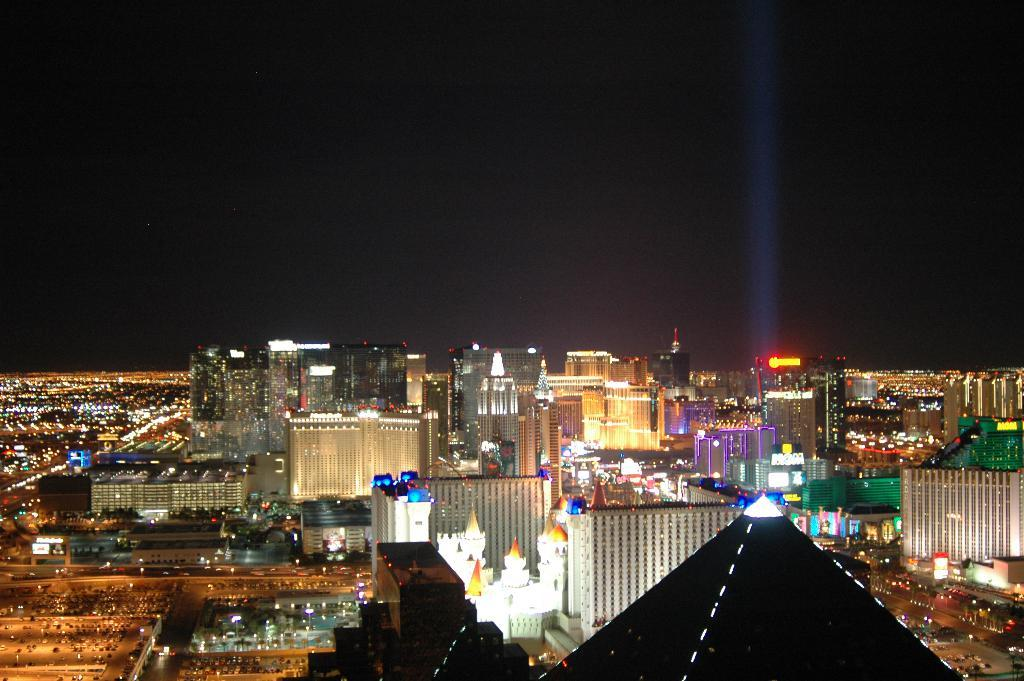What type of location is depicted in the image? The image shows a view of a city. What features of the city can be seen in the image? There are buildings with lights and roads visible in the image. Are there any specific details about the buildings in the image? Yes, there are name boards at the top of some buildings in the image. How does the duck increase its respect in the image? There is no duck present in the image, so it cannot increase its respect. 